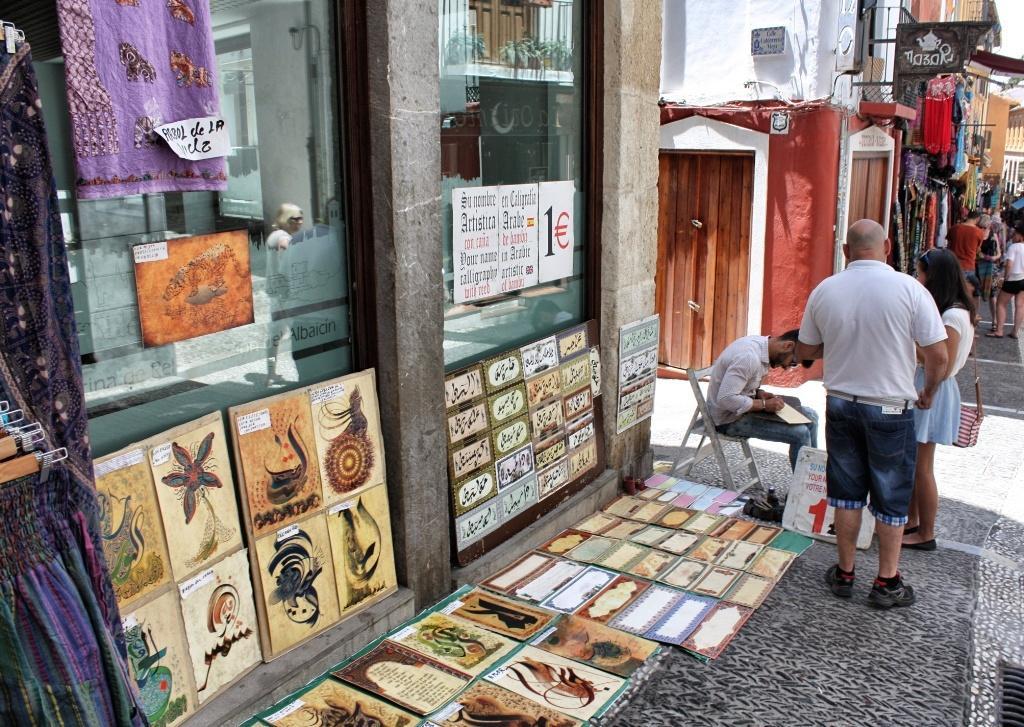Describe this image in one or two sentences. In the image on the left there is a building,glass,clothes,hangers,banners and frames. In the center of the image we can see three persons were holding some objects. In the background we can see buildings,door,clothes,banners and few people were standing. 